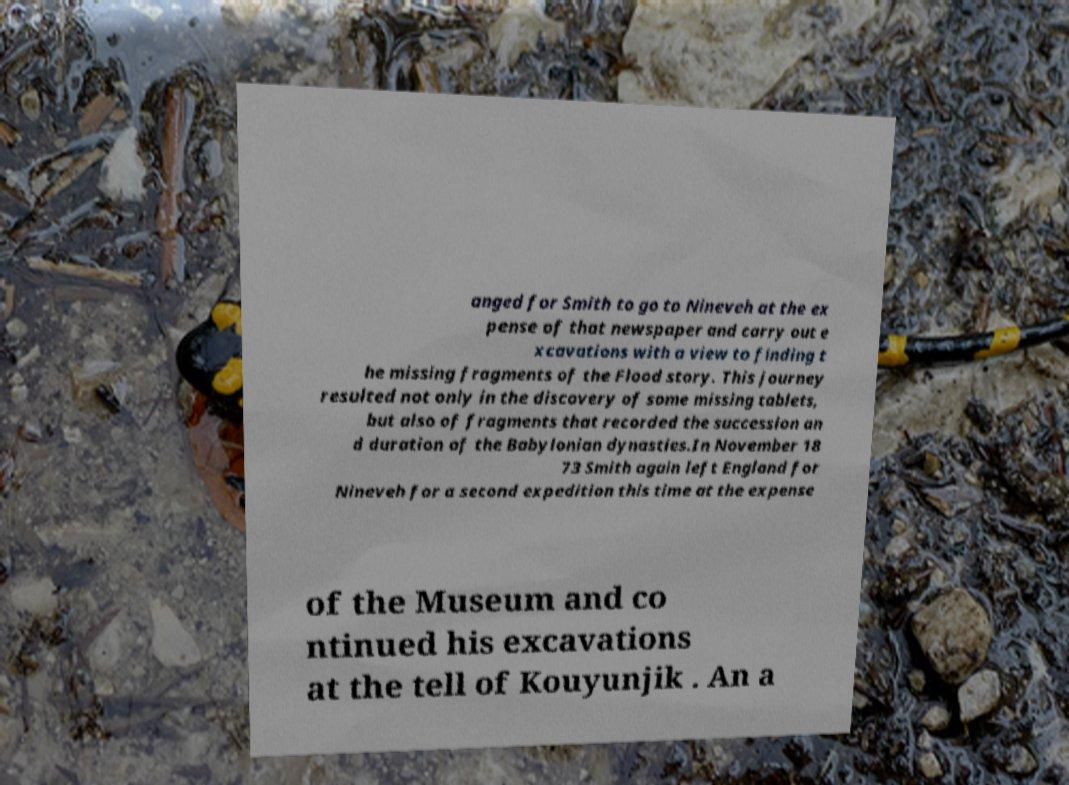Could you assist in decoding the text presented in this image and type it out clearly? anged for Smith to go to Nineveh at the ex pense of that newspaper and carry out e xcavations with a view to finding t he missing fragments of the Flood story. This journey resulted not only in the discovery of some missing tablets, but also of fragments that recorded the succession an d duration of the Babylonian dynasties.In November 18 73 Smith again left England for Nineveh for a second expedition this time at the expense of the Museum and co ntinued his excavations at the tell of Kouyunjik . An a 